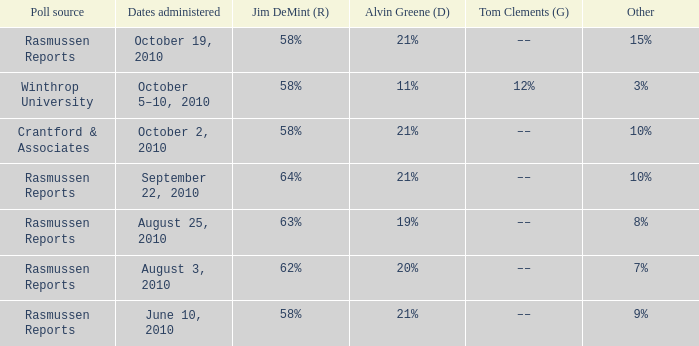Which poll source had an other of 15%? Rasmussen Reports. 